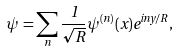Convert formula to latex. <formula><loc_0><loc_0><loc_500><loc_500>\psi = \sum _ { n } \frac { 1 } { \sqrt { R } } \psi ^ { ( n ) } ( x ) e ^ { i n y / R } ,</formula> 